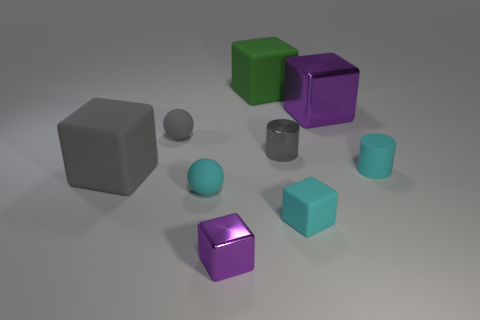Add 1 small gray cylinders. How many objects exist? 10 Subtract all large gray rubber cubes. How many cubes are left? 4 Subtract all cyan cylinders. How many purple blocks are left? 2 Subtract 1 spheres. How many spheres are left? 1 Subtract all cubes. How many objects are left? 4 Subtract 0 yellow cylinders. How many objects are left? 9 Subtract all purple spheres. Subtract all blue cubes. How many spheres are left? 2 Subtract all tiny objects. Subtract all tiny blue cylinders. How many objects are left? 3 Add 7 green blocks. How many green blocks are left? 8 Add 3 cyan rubber cylinders. How many cyan rubber cylinders exist? 4 